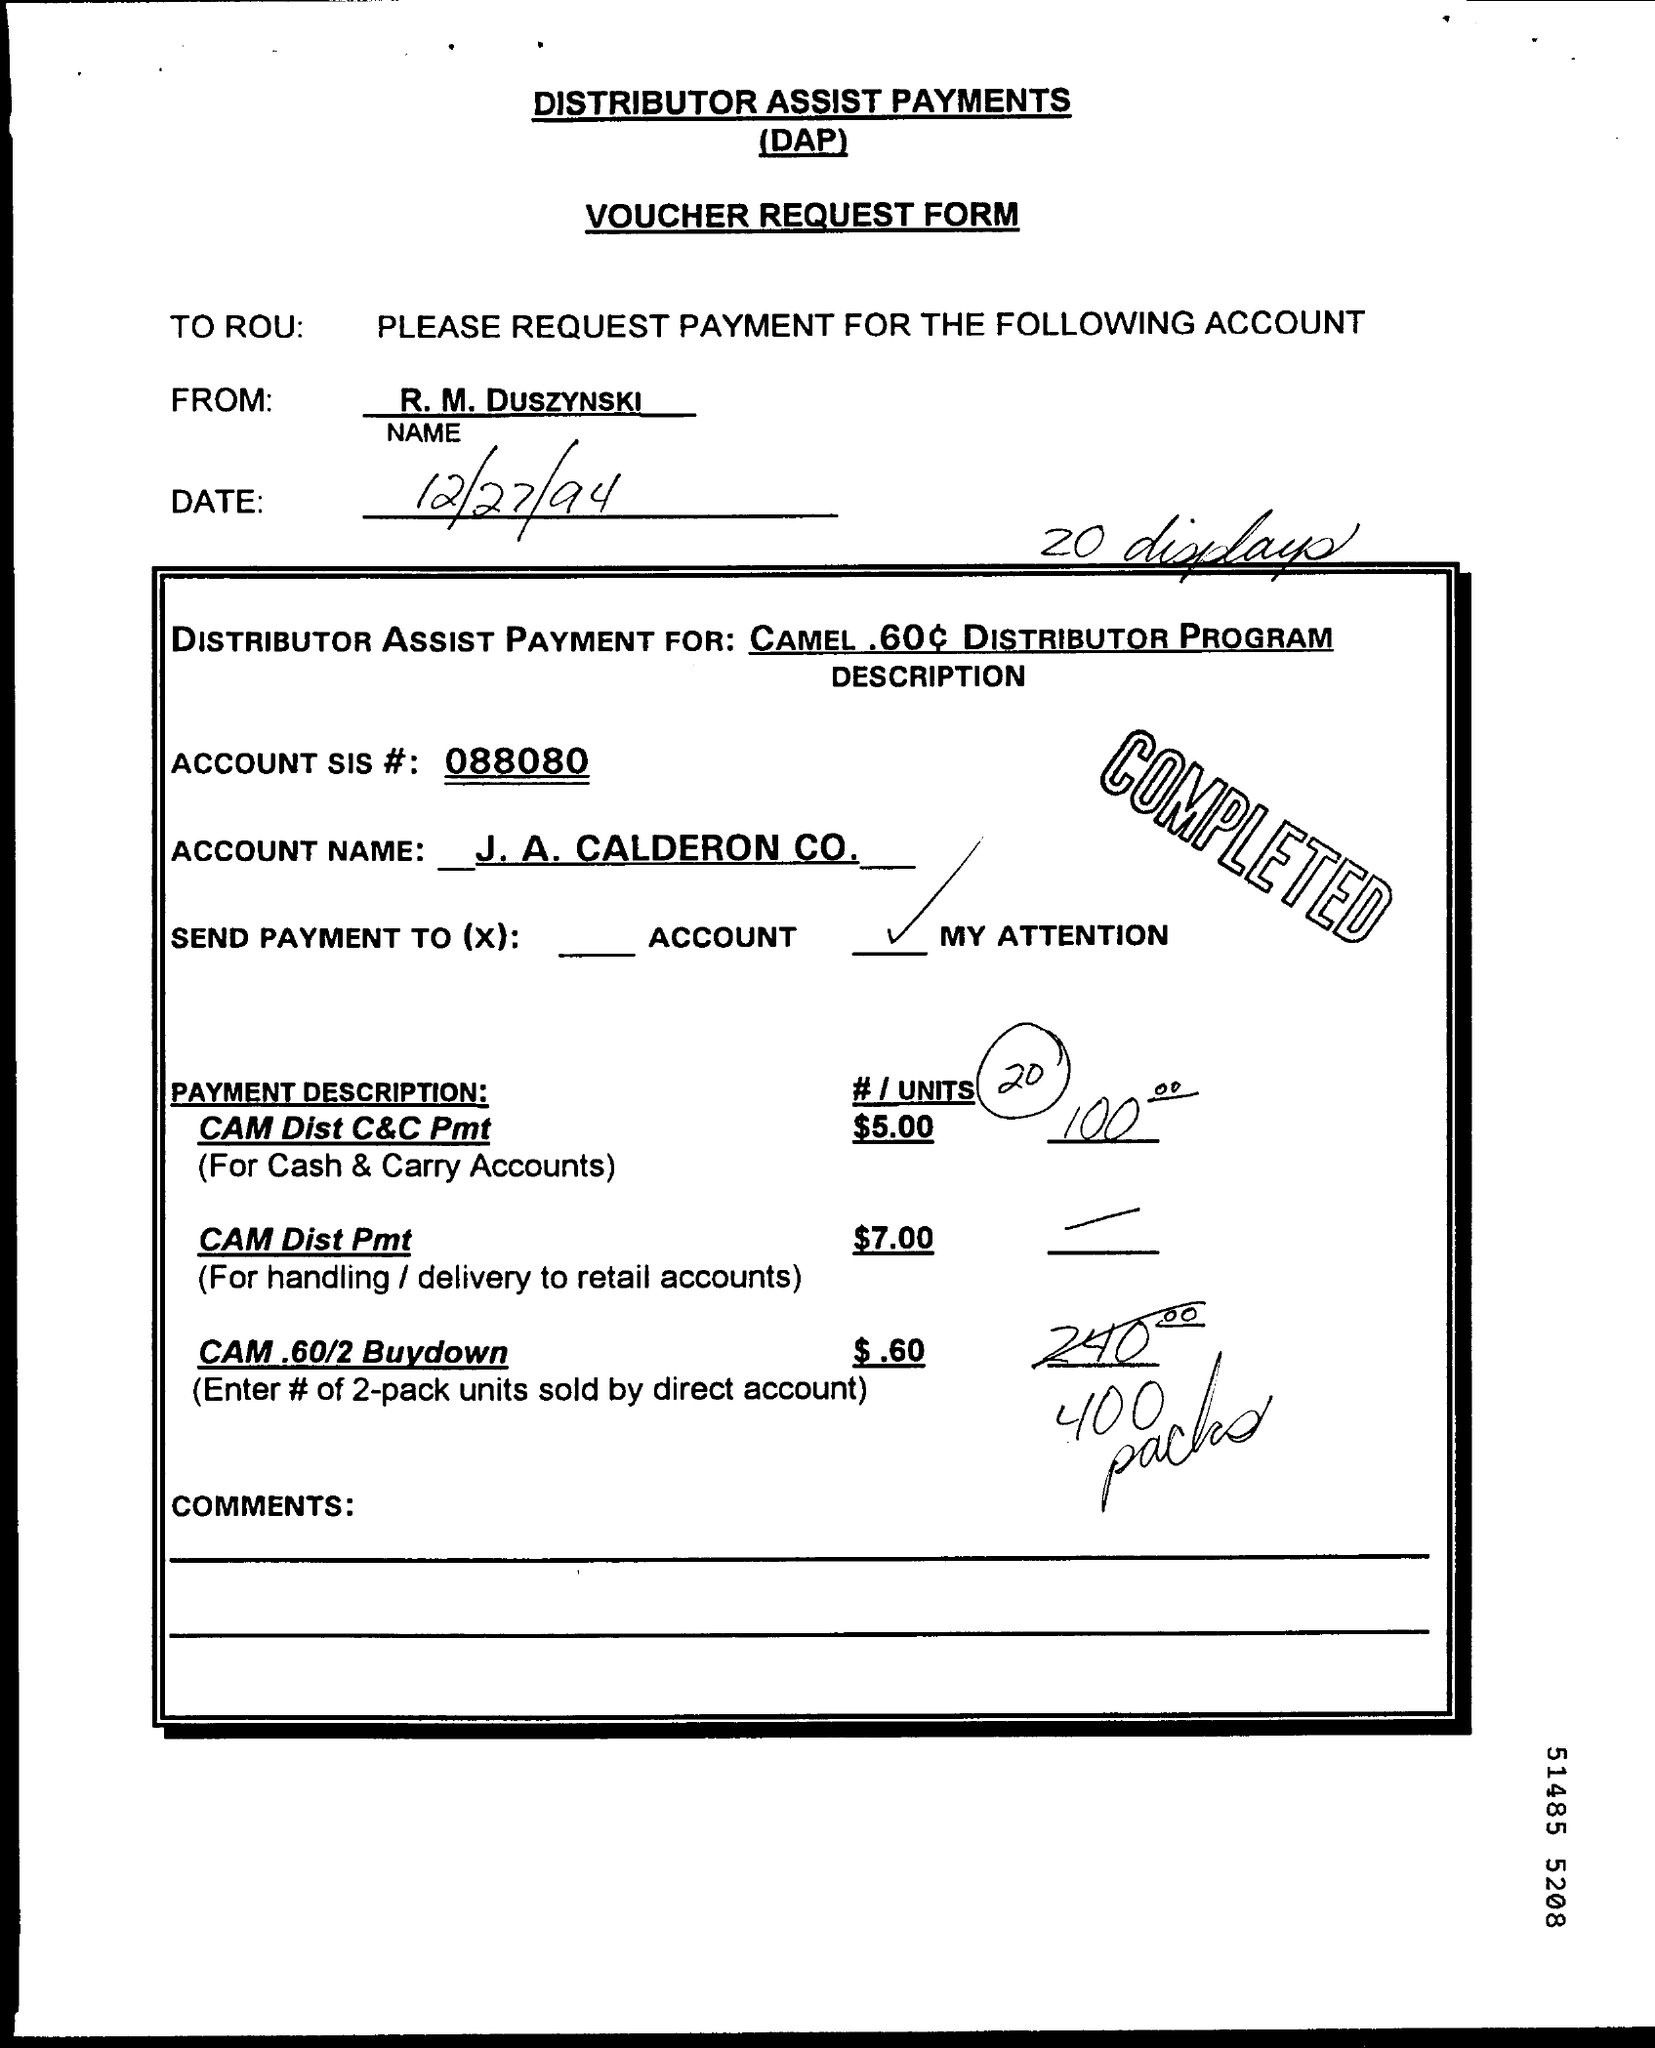Specify some key components in this picture. The full form of DAP is Distributor Assist Payments, which refers to payments made by a distributor to assist a supplier in the distribution of their products. 